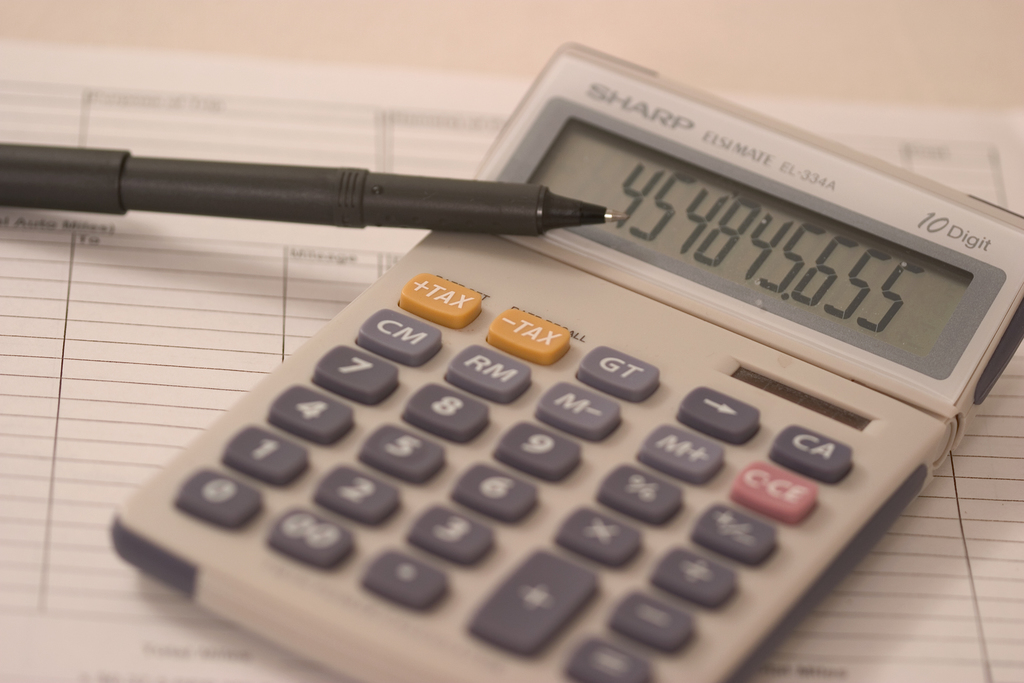How do the items like the pen and paper complement the use of a calculator in this setting? Items like pens and paper play a crucial role in complementing the use of calculators in business or accounting settings. While calculators allow for rapid and accurate computations, pens and paper are indispensable for recording these results, making annotations, or adjusting figures based on calculations. They enable a tangible trail of written records that is beneficial for audits, reference, or further analysis. This traditional use of both digital and manual tools ensures a complete and reliable financial management process. 